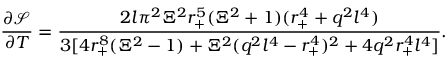<formula> <loc_0><loc_0><loc_500><loc_500>\frac { \partial \mathcal { S } } { \partial T } = \frac { 2 l \pi ^ { 2 } \Xi ^ { 2 } r _ { + } ^ { 5 } ( \Xi ^ { 2 } + 1 ) ( r _ { + } ^ { 4 } + q ^ { 2 } l ^ { 4 } ) } { 3 [ 4 r _ { + } ^ { 8 } ( \Xi ^ { 2 } - 1 ) + \Xi ^ { 2 } ( q ^ { 2 } l ^ { 4 } - r _ { + } ^ { 4 } ) ^ { 2 } + 4 q ^ { 2 } r _ { + } ^ { 4 } l ^ { 4 } ] } .</formula> 